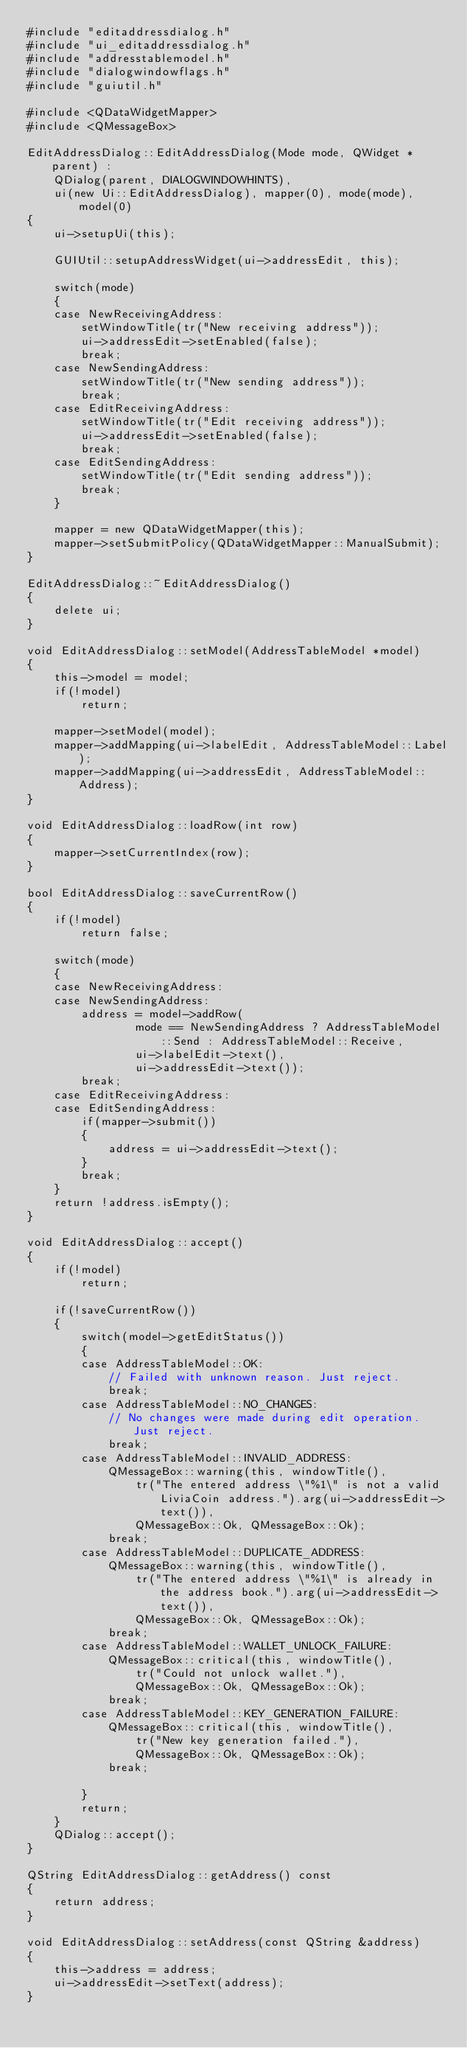Convert code to text. <code><loc_0><loc_0><loc_500><loc_500><_C++_>#include "editaddressdialog.h"
#include "ui_editaddressdialog.h"
#include "addresstablemodel.h"
#include "dialogwindowflags.h"
#include "guiutil.h"

#include <QDataWidgetMapper>
#include <QMessageBox>

EditAddressDialog::EditAddressDialog(Mode mode, QWidget *parent) :
    QDialog(parent, DIALOGWINDOWHINTS),
    ui(new Ui::EditAddressDialog), mapper(0), mode(mode), model(0)
{
    ui->setupUi(this);

    GUIUtil::setupAddressWidget(ui->addressEdit, this);

    switch(mode)
    {
    case NewReceivingAddress:
        setWindowTitle(tr("New receiving address"));
        ui->addressEdit->setEnabled(false);
        break;
    case NewSendingAddress:
        setWindowTitle(tr("New sending address"));
        break;
    case EditReceivingAddress:
        setWindowTitle(tr("Edit receiving address"));
        ui->addressEdit->setEnabled(false);
        break;
    case EditSendingAddress:
        setWindowTitle(tr("Edit sending address"));
        break;
    }

    mapper = new QDataWidgetMapper(this);
    mapper->setSubmitPolicy(QDataWidgetMapper::ManualSubmit);
}

EditAddressDialog::~EditAddressDialog()
{
    delete ui;
}

void EditAddressDialog::setModel(AddressTableModel *model)
{
    this->model = model;
    if(!model)
        return;

    mapper->setModel(model);
    mapper->addMapping(ui->labelEdit, AddressTableModel::Label);
    mapper->addMapping(ui->addressEdit, AddressTableModel::Address);
}

void EditAddressDialog::loadRow(int row)
{
    mapper->setCurrentIndex(row);
}

bool EditAddressDialog::saveCurrentRow()
{
    if(!model)
        return false;

    switch(mode)
    {
    case NewReceivingAddress:
    case NewSendingAddress:
        address = model->addRow(
                mode == NewSendingAddress ? AddressTableModel::Send : AddressTableModel::Receive,
                ui->labelEdit->text(),
                ui->addressEdit->text());
        break;
    case EditReceivingAddress:
    case EditSendingAddress:
        if(mapper->submit())
        {
            address = ui->addressEdit->text();
        }
        break;
    }
    return !address.isEmpty();
}

void EditAddressDialog::accept()
{
    if(!model)
        return;

    if(!saveCurrentRow())
    {
        switch(model->getEditStatus())
        {
        case AddressTableModel::OK:
            // Failed with unknown reason. Just reject.
            break;
        case AddressTableModel::NO_CHANGES:
            // No changes were made during edit operation. Just reject.
            break;
        case AddressTableModel::INVALID_ADDRESS:
            QMessageBox::warning(this, windowTitle(),
                tr("The entered address \"%1\" is not a valid LiviaCoin address.").arg(ui->addressEdit->text()),
                QMessageBox::Ok, QMessageBox::Ok);
            break;
        case AddressTableModel::DUPLICATE_ADDRESS:
            QMessageBox::warning(this, windowTitle(),
                tr("The entered address \"%1\" is already in the address book.").arg(ui->addressEdit->text()),
                QMessageBox::Ok, QMessageBox::Ok);
            break;
        case AddressTableModel::WALLET_UNLOCK_FAILURE:
            QMessageBox::critical(this, windowTitle(),
                tr("Could not unlock wallet."),
                QMessageBox::Ok, QMessageBox::Ok);
            break;
        case AddressTableModel::KEY_GENERATION_FAILURE:
            QMessageBox::critical(this, windowTitle(),
                tr("New key generation failed."),
                QMessageBox::Ok, QMessageBox::Ok);
            break;

        }
        return;
    }
    QDialog::accept();
}

QString EditAddressDialog::getAddress() const
{
    return address;
}

void EditAddressDialog::setAddress(const QString &address)
{
    this->address = address;
    ui->addressEdit->setText(address);
}
</code> 